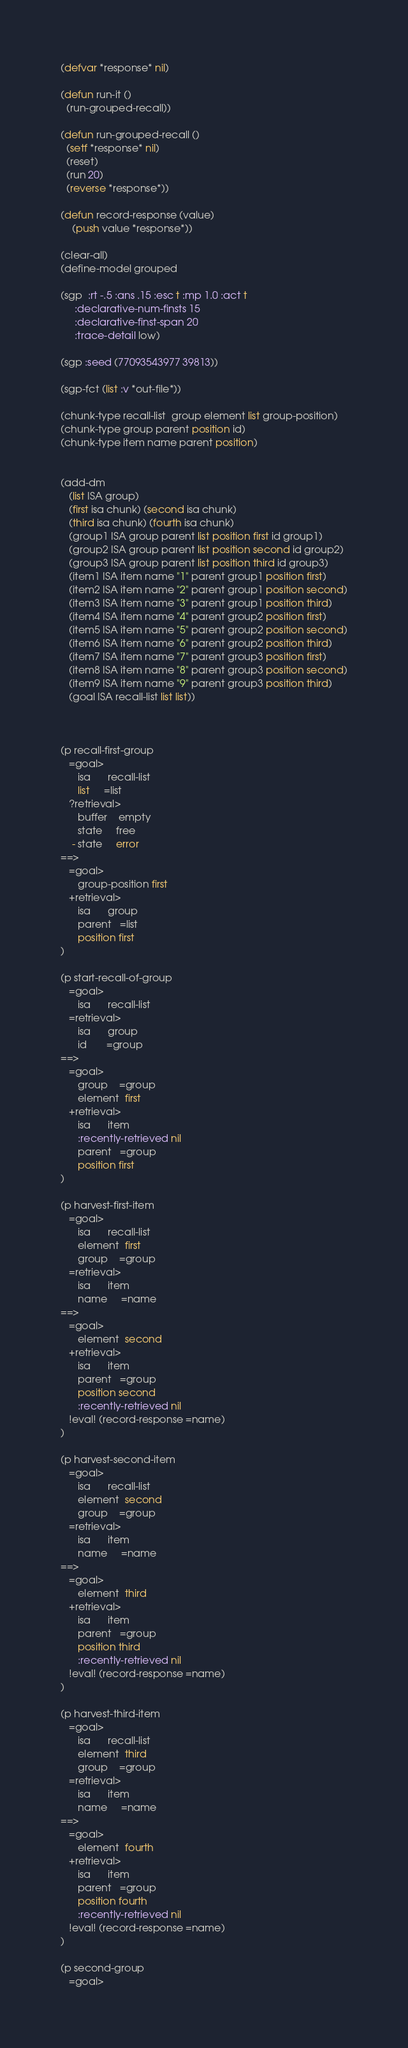<code> <loc_0><loc_0><loc_500><loc_500><_Lisp_>(defvar *response* nil)

(defun run-it ()
  (run-grouped-recall))

(defun run-grouped-recall ()
  (setf *response* nil)
  (reset)
  (run 20)
  (reverse *response*))

(defun record-response (value)
    (push value *response*))

(clear-all)
(define-model grouped

(sgp  :rt -.5 :ans .15 :esc t :mp 1.0 :act t
     :declarative-num-finsts 15
     :declarative-finst-span 20
     :trace-detail low)

(sgp :seed (77093543977 39813))

(sgp-fct (list :v *out-file*))

(chunk-type recall-list  group element list group-position)
(chunk-type group parent position id)
(chunk-type item name parent position)


(add-dm
   (list ISA group)
   (first isa chunk) (second isa chunk)
   (third isa chunk) (fourth isa chunk)
   (group1 ISA group parent list position first id group1)
   (group2 ISA group parent list position second id group2)
   (group3 ISA group parent list position third id group3)
   (item1 ISA item name "1" parent group1 position first)
   (item2 ISA item name "2" parent group1 position second)
   (item3 ISA item name "3" parent group1 position third)
   (item4 ISA item name "4" parent group2 position first)
   (item5 ISA item name "5" parent group2 position second)
   (item6 ISA item name "6" parent group2 position third)
   (item7 ISA item name "7" parent group3 position first)
   (item8 ISA item name "8" parent group3 position second)
   (item9 ISA item name "9" parent group3 position third)
   (goal ISA recall-list list list))



(p recall-first-group
   =goal>
      isa      recall-list
      list     =list
   ?retrieval>
      buffer    empty
      state     free
    - state     error
==>
   =goal>
      group-position first
   +retrieval>
      isa      group
      parent   =list
      position first
)

(p start-recall-of-group
   =goal>
      isa      recall-list
   =retrieval>
      isa      group
      id       =group
==>    
   =goal>
      group    =group 
      element  first
   +retrieval>
      isa      item
      :recently-retrieved nil
      parent   =group
      position first
)

(p harvest-first-item
   =goal>
      isa      recall-list
      element  first
      group    =group
   =retrieval>
      isa      item
      name     =name
==>
   =goal>
      element  second
   +retrieval>
      isa      item
      parent   =group
      position second 
      :recently-retrieved nil
   !eval! (record-response =name)
)

(p harvest-second-item
   =goal>
      isa      recall-list
      element  second
      group    =group
   =retrieval>
      isa      item
      name     =name
==>
   =goal>
      element  third
   +retrieval>
      isa      item
      parent   =group
      position third
      :recently-retrieved nil
   !eval! (record-response =name)
)

(p harvest-third-item
   =goal>
      isa      recall-list
      element  third
      group    =group
   =retrieval>
      isa      item
      name     =name
==>
   =goal>
      element  fourth
   +retrieval>
      isa      item
      parent   =group
      position fourth
      :recently-retrieved nil
   !eval! (record-response =name)
)

(p second-group
   =goal></code> 